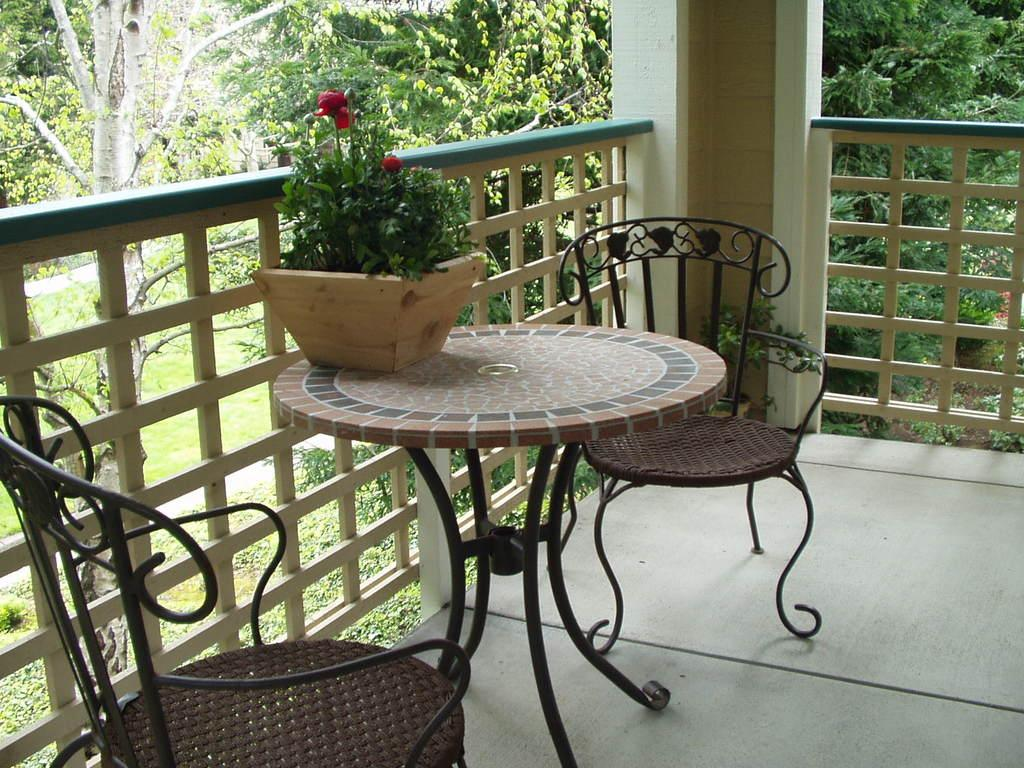What is placed on the table in the image? There is a flower pot on a table in the image. Where is the table located? The table is in a balcony. What type of furniture is present in the balcony? There are two chairs in the balcony. What can be seen in the background of the balcony? There are trees around the balcony. What type of cub can be seen playing with the cream in the image? There is no cub or cream present in the image. How many windows are visible in the image? The image does not show any windows; it features a flower pot on a table in a balcony. 